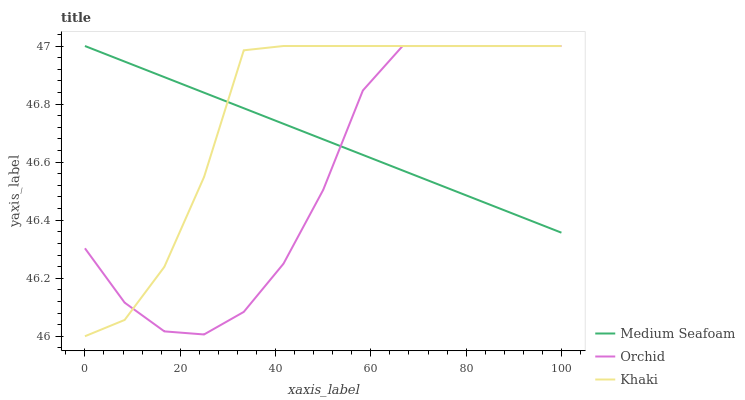Does Orchid have the minimum area under the curve?
Answer yes or no. Yes. Does Khaki have the maximum area under the curve?
Answer yes or no. Yes. Does Medium Seafoam have the minimum area under the curve?
Answer yes or no. No. Does Medium Seafoam have the maximum area under the curve?
Answer yes or no. No. Is Medium Seafoam the smoothest?
Answer yes or no. Yes. Is Orchid the roughest?
Answer yes or no. Yes. Is Orchid the smoothest?
Answer yes or no. No. Is Medium Seafoam the roughest?
Answer yes or no. No. Does Khaki have the lowest value?
Answer yes or no. Yes. Does Orchid have the lowest value?
Answer yes or no. No. Does Orchid have the highest value?
Answer yes or no. Yes. Does Khaki intersect Medium Seafoam?
Answer yes or no. Yes. Is Khaki less than Medium Seafoam?
Answer yes or no. No. Is Khaki greater than Medium Seafoam?
Answer yes or no. No. 